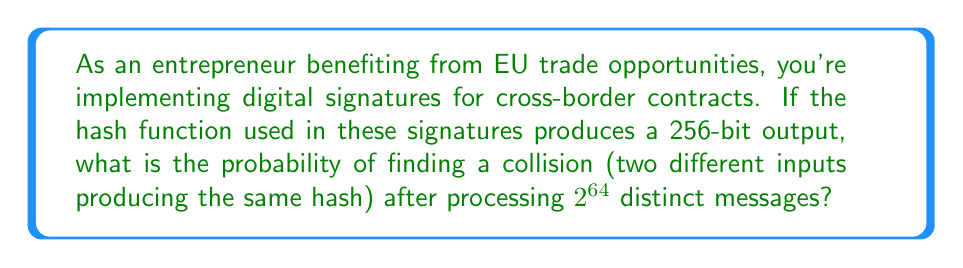Can you answer this question? To solve this problem, we'll use the birthday attack probability formula and follow these steps:

1) The birthday attack probability for a hash function with an n-bit output after q queries is approximately:

   $P(\text{collision}) \approx 1 - e^{-q^2/(2^{n+1})}$

2) In this case:
   $n = 256$ (256-bit output)
   $q = 2^{64}$ (number of processed messages)

3) Substituting these values into the formula:

   $P(\text{collision}) \approx 1 - e^{-(2^{64})^2/(2^{257})}$

4) Simplify the exponent:
   $(2^{64})^2 = 2^{128}$
   $2^{257} = 2 \cdot 2^{256}$

   $P(\text{collision}) \approx 1 - e^{-2^{128}/(2 \cdot 2^{256})}$

5) Further simplification:
   $2^{128}/(2 \cdot 2^{256}) = 2^{128}/(2^{257}) = 2^{128-257} = 2^{-129}$

   $P(\text{collision}) \approx 1 - e^{-2^{-129}}$

6) Using the Taylor expansion of $e^x$ for small x:
   $e^x \approx 1 + x$ for small x

   $P(\text{collision}) \approx 1 - (1 - 2^{-129})$

7) Final calculation:
   $P(\text{collision}) \approx 2^{-129}$

This extremely small probability demonstrates the high collision resistance of 256-bit hash functions, ensuring the security of digital signatures in EU contracts.
Answer: $2^{-129}$ 